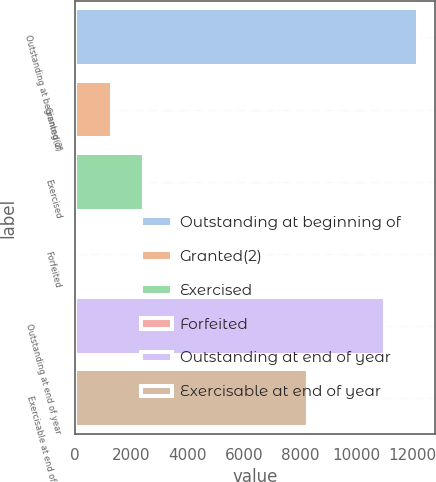Convert chart. <chart><loc_0><loc_0><loc_500><loc_500><bar_chart><fcel>Outstanding at beginning of<fcel>Granted(2)<fcel>Exercised<fcel>Forfeited<fcel>Outstanding at end of year<fcel>Exercisable at end of year<nl><fcel>12196.6<fcel>1297<fcel>2460.6<fcel>40<fcel>11033<fcel>8276<nl></chart> 